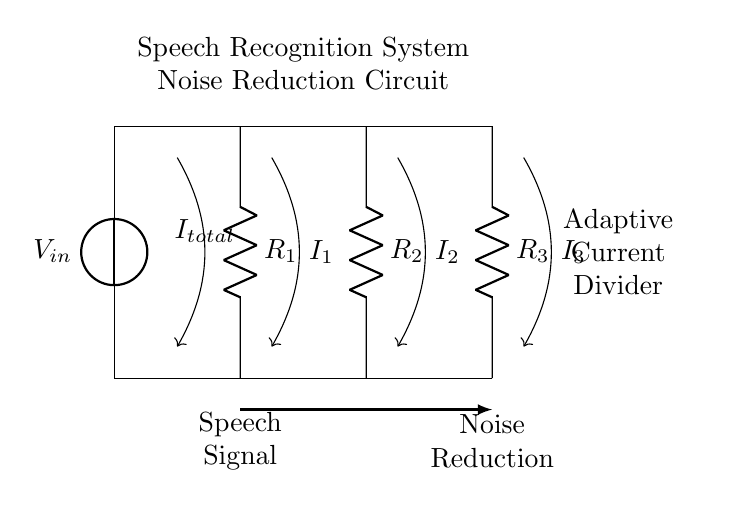What is the total current in this circuit? The total current, denoted as I_total, represents the sum of currents flowing through the resistors in the circuit. It is indicated by the arrow labeled I_total in the diagram, which suggests its presence in the circuit.
Answer: I_total What are the resistors used in this circuit? The resistors present in this circuit are labeled as R_1, R_2, and R_3. Each resistor is part of the current divider configuration, and they can be identified by their respective labels shown in the diagram.
Answer: R_1, R_2, R_3 What does the arrow pointing to the speech signal represent? The arrow labeled "Speech Signal" indicates the specific component of interest in this circuit, which is the input for the noise reduction process in the speech recognition system. This clarifies that part of the circuit operates specifically to handle speech signals.
Answer: Speech Signal How does the adaptive current divider impact noise reduction? The adaptive current divider is designed to optimize the splitting of currents through the resistors, effectively managing how much signal is processed versus how much noise is filtered out. The presence of the label "Noise Reduction" below the circuit indicates that this functionality is intended to enhance the clarity of the processed speech signal, demonstrating its importance in speech recognition applications.
Answer: Optimizes noise reduction What is the relationship between the different resistors in the current divider? The relationship is defined by the concept of current division, where the total current entering the circuit is divided among the resistors based on their resistance values. The currents I_1, I_2, and I_3 flowing through R_1, R_2, and R_3, respectively, depend on their resistances according to the current divider rule, which states that the current through each resistor is inversely proportional to its resistance.
Answer: Inversely proportional 